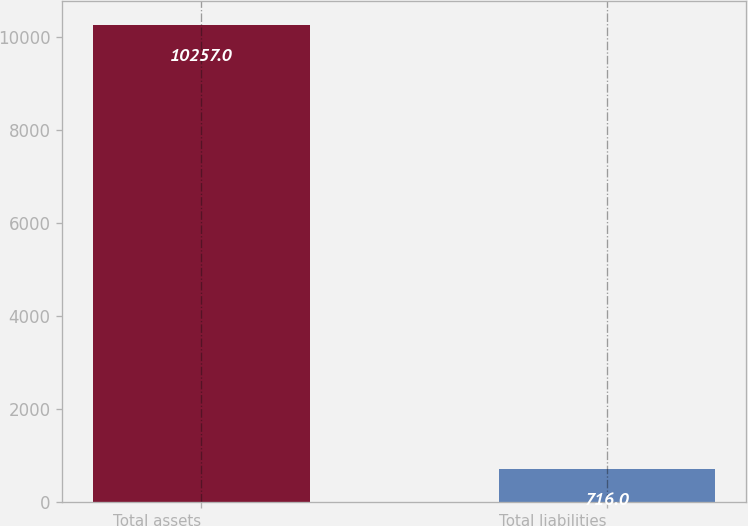<chart> <loc_0><loc_0><loc_500><loc_500><bar_chart><fcel>Total assets<fcel>Total liabilities<nl><fcel>10257<fcel>716<nl></chart> 